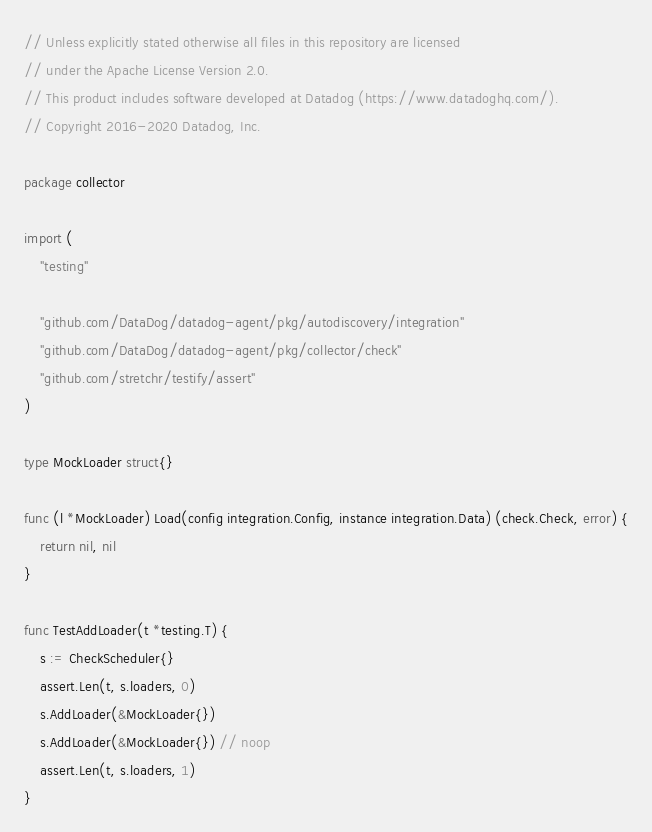Convert code to text. <code><loc_0><loc_0><loc_500><loc_500><_Go_>// Unless explicitly stated otherwise all files in this repository are licensed
// under the Apache License Version 2.0.
// This product includes software developed at Datadog (https://www.datadoghq.com/).
// Copyright 2016-2020 Datadog, Inc.

package collector

import (
	"testing"

	"github.com/DataDog/datadog-agent/pkg/autodiscovery/integration"
	"github.com/DataDog/datadog-agent/pkg/collector/check"
	"github.com/stretchr/testify/assert"
)

type MockLoader struct{}

func (l *MockLoader) Load(config integration.Config, instance integration.Data) (check.Check, error) {
	return nil, nil
}

func TestAddLoader(t *testing.T) {
	s := CheckScheduler{}
	assert.Len(t, s.loaders, 0)
	s.AddLoader(&MockLoader{})
	s.AddLoader(&MockLoader{}) // noop
	assert.Len(t, s.loaders, 1)
}
</code> 